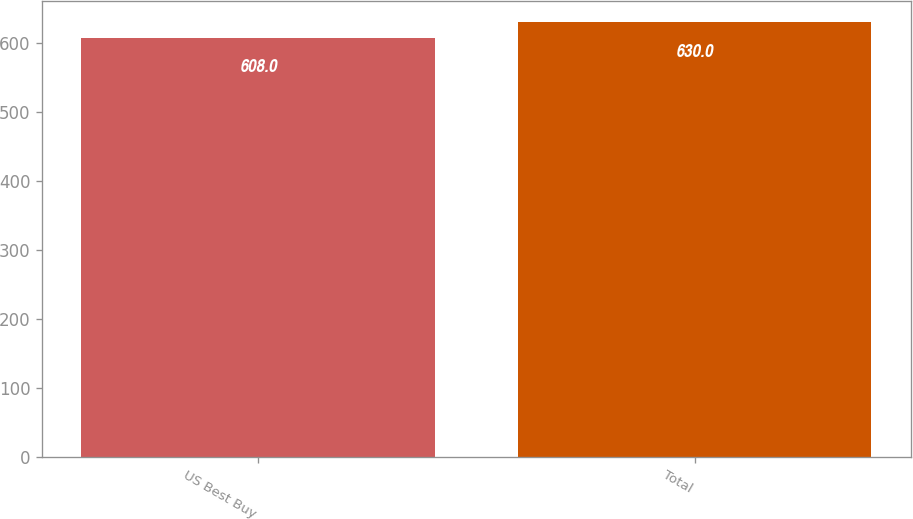Convert chart to OTSL. <chart><loc_0><loc_0><loc_500><loc_500><bar_chart><fcel>US Best Buy<fcel>Total<nl><fcel>608<fcel>630<nl></chart> 